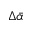Convert formula to latex. <formula><loc_0><loc_0><loc_500><loc_500>\Delta \ B a r { \alpha }</formula> 